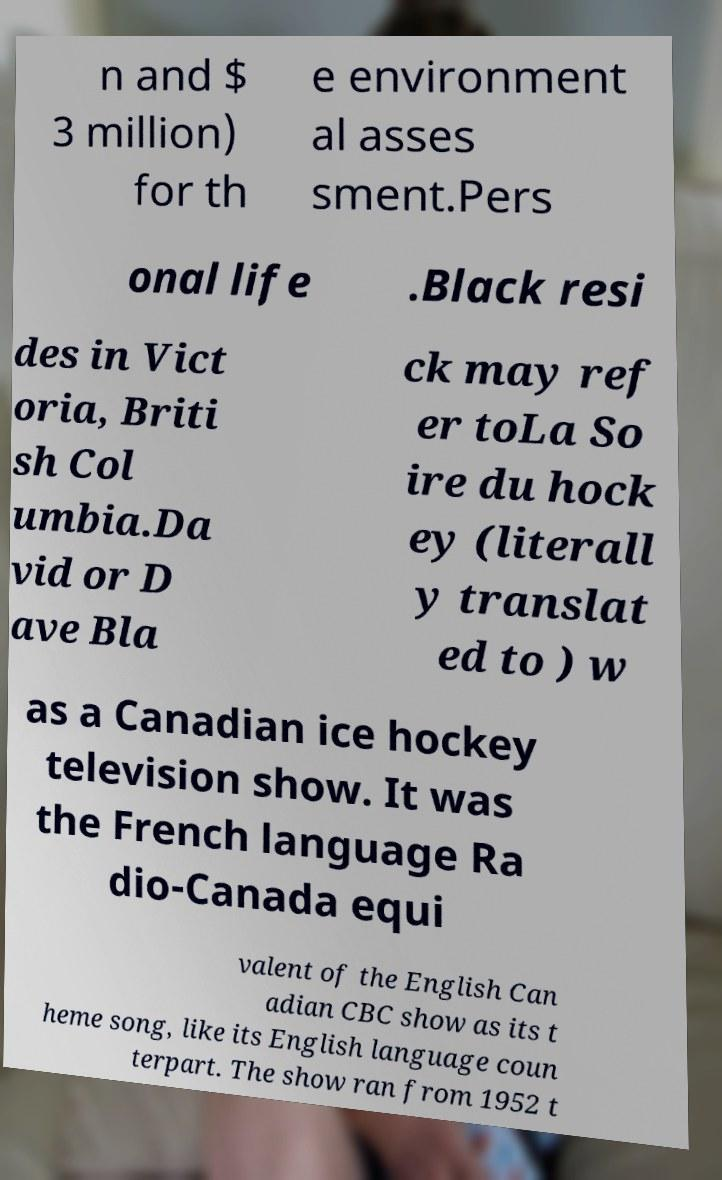Can you read and provide the text displayed in the image?This photo seems to have some interesting text. Can you extract and type it out for me? n and $ 3 million) for th e environment al asses sment.Pers onal life .Black resi des in Vict oria, Briti sh Col umbia.Da vid or D ave Bla ck may ref er toLa So ire du hock ey (literall y translat ed to ) w as a Canadian ice hockey television show. It was the French language Ra dio-Canada equi valent of the English Can adian CBC show as its t heme song, like its English language coun terpart. The show ran from 1952 t 